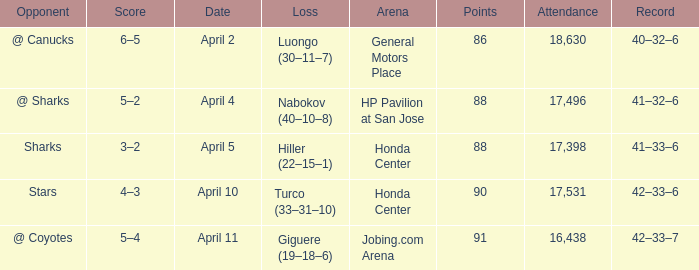Which Attendance has more than 90 points? 16438.0. 